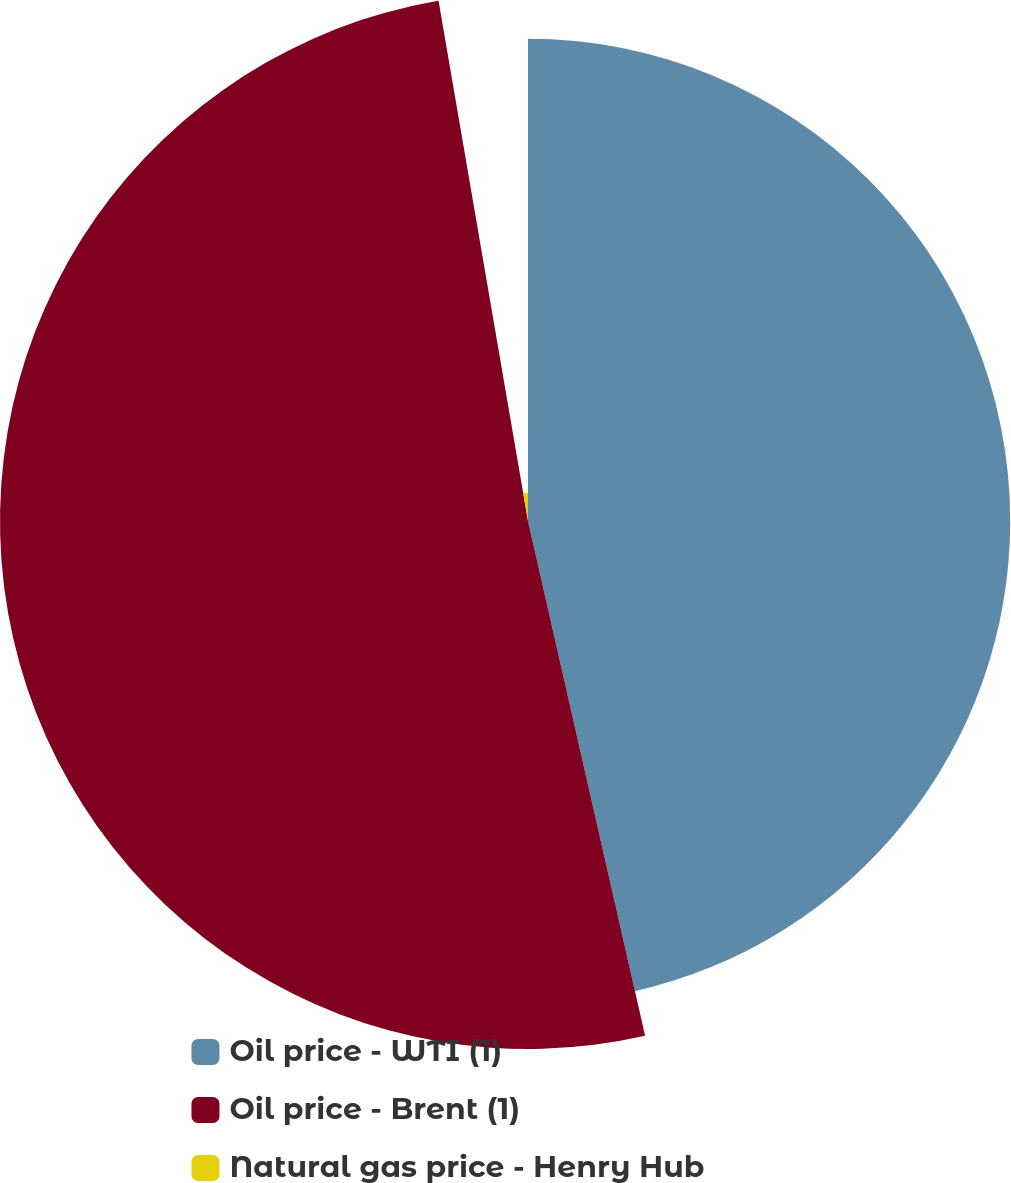<chart> <loc_0><loc_0><loc_500><loc_500><pie_chart><fcel>Oil price - WTI (1)<fcel>Oil price - Brent (1)<fcel>Natural gas price - Henry Hub<nl><fcel>46.44%<fcel>50.85%<fcel>2.71%<nl></chart> 